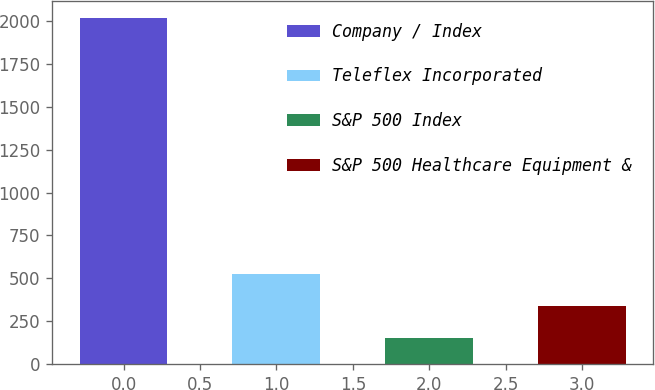Convert chart. <chart><loc_0><loc_0><loc_500><loc_500><bar_chart><fcel>Company / Index<fcel>Teleflex Incorporated<fcel>S&P 500 Index<fcel>S&P 500 Healthcare Equipment &<nl><fcel>2014<fcel>523.6<fcel>151<fcel>337.3<nl></chart> 